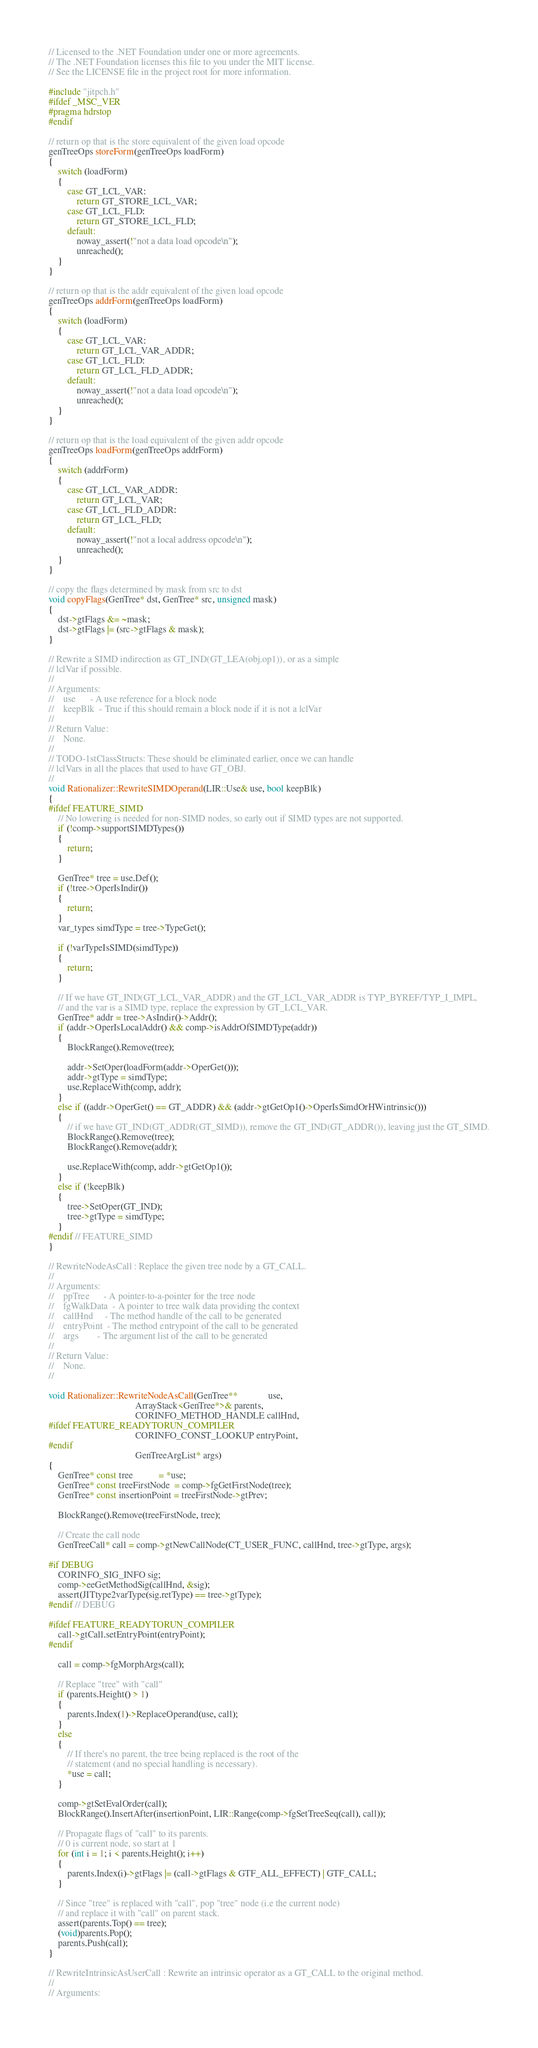Convert code to text. <code><loc_0><loc_0><loc_500><loc_500><_C++_>// Licensed to the .NET Foundation under one or more agreements.
// The .NET Foundation licenses this file to you under the MIT license.
// See the LICENSE file in the project root for more information.

#include "jitpch.h"
#ifdef _MSC_VER
#pragma hdrstop
#endif

// return op that is the store equivalent of the given load opcode
genTreeOps storeForm(genTreeOps loadForm)
{
    switch (loadForm)
    {
        case GT_LCL_VAR:
            return GT_STORE_LCL_VAR;
        case GT_LCL_FLD:
            return GT_STORE_LCL_FLD;
        default:
            noway_assert(!"not a data load opcode\n");
            unreached();
    }
}

// return op that is the addr equivalent of the given load opcode
genTreeOps addrForm(genTreeOps loadForm)
{
    switch (loadForm)
    {
        case GT_LCL_VAR:
            return GT_LCL_VAR_ADDR;
        case GT_LCL_FLD:
            return GT_LCL_FLD_ADDR;
        default:
            noway_assert(!"not a data load opcode\n");
            unreached();
    }
}

// return op that is the load equivalent of the given addr opcode
genTreeOps loadForm(genTreeOps addrForm)
{
    switch (addrForm)
    {
        case GT_LCL_VAR_ADDR:
            return GT_LCL_VAR;
        case GT_LCL_FLD_ADDR:
            return GT_LCL_FLD;
        default:
            noway_assert(!"not a local address opcode\n");
            unreached();
    }
}

// copy the flags determined by mask from src to dst
void copyFlags(GenTree* dst, GenTree* src, unsigned mask)
{
    dst->gtFlags &= ~mask;
    dst->gtFlags |= (src->gtFlags & mask);
}

// Rewrite a SIMD indirection as GT_IND(GT_LEA(obj.op1)), or as a simple
// lclVar if possible.
//
// Arguments:
//    use      - A use reference for a block node
//    keepBlk  - True if this should remain a block node if it is not a lclVar
//
// Return Value:
//    None.
//
// TODO-1stClassStructs: These should be eliminated earlier, once we can handle
// lclVars in all the places that used to have GT_OBJ.
//
void Rationalizer::RewriteSIMDOperand(LIR::Use& use, bool keepBlk)
{
#ifdef FEATURE_SIMD
    // No lowering is needed for non-SIMD nodes, so early out if SIMD types are not supported.
    if (!comp->supportSIMDTypes())
    {
        return;
    }

    GenTree* tree = use.Def();
    if (!tree->OperIsIndir())
    {
        return;
    }
    var_types simdType = tree->TypeGet();

    if (!varTypeIsSIMD(simdType))
    {
        return;
    }

    // If we have GT_IND(GT_LCL_VAR_ADDR) and the GT_LCL_VAR_ADDR is TYP_BYREF/TYP_I_IMPL,
    // and the var is a SIMD type, replace the expression by GT_LCL_VAR.
    GenTree* addr = tree->AsIndir()->Addr();
    if (addr->OperIsLocalAddr() && comp->isAddrOfSIMDType(addr))
    {
        BlockRange().Remove(tree);

        addr->SetOper(loadForm(addr->OperGet()));
        addr->gtType = simdType;
        use.ReplaceWith(comp, addr);
    }
    else if ((addr->OperGet() == GT_ADDR) && (addr->gtGetOp1()->OperIsSimdOrHWintrinsic()))
    {
        // if we have GT_IND(GT_ADDR(GT_SIMD)), remove the GT_IND(GT_ADDR()), leaving just the GT_SIMD.
        BlockRange().Remove(tree);
        BlockRange().Remove(addr);

        use.ReplaceWith(comp, addr->gtGetOp1());
    }
    else if (!keepBlk)
    {
        tree->SetOper(GT_IND);
        tree->gtType = simdType;
    }
#endif // FEATURE_SIMD
}

// RewriteNodeAsCall : Replace the given tree node by a GT_CALL.
//
// Arguments:
//    ppTree      - A pointer-to-a-pointer for the tree node
//    fgWalkData  - A pointer to tree walk data providing the context
//    callHnd     - The method handle of the call to be generated
//    entryPoint  - The method entrypoint of the call to be generated
//    args        - The argument list of the call to be generated
//
// Return Value:
//    None.
//

void Rationalizer::RewriteNodeAsCall(GenTree**             use,
                                     ArrayStack<GenTree*>& parents,
                                     CORINFO_METHOD_HANDLE callHnd,
#ifdef FEATURE_READYTORUN_COMPILER
                                     CORINFO_CONST_LOOKUP entryPoint,
#endif
                                     GenTreeArgList* args)
{
    GenTree* const tree           = *use;
    GenTree* const treeFirstNode  = comp->fgGetFirstNode(tree);
    GenTree* const insertionPoint = treeFirstNode->gtPrev;

    BlockRange().Remove(treeFirstNode, tree);

    // Create the call node
    GenTreeCall* call = comp->gtNewCallNode(CT_USER_FUNC, callHnd, tree->gtType, args);

#if DEBUG
    CORINFO_SIG_INFO sig;
    comp->eeGetMethodSig(callHnd, &sig);
    assert(JITtype2varType(sig.retType) == tree->gtType);
#endif // DEBUG

#ifdef FEATURE_READYTORUN_COMPILER
    call->gtCall.setEntryPoint(entryPoint);
#endif

    call = comp->fgMorphArgs(call);

    // Replace "tree" with "call"
    if (parents.Height() > 1)
    {
        parents.Index(1)->ReplaceOperand(use, call);
    }
    else
    {
        // If there's no parent, the tree being replaced is the root of the
        // statement (and no special handling is necessary).
        *use = call;
    }

    comp->gtSetEvalOrder(call);
    BlockRange().InsertAfter(insertionPoint, LIR::Range(comp->fgSetTreeSeq(call), call));

    // Propagate flags of "call" to its parents.
    // 0 is current node, so start at 1
    for (int i = 1; i < parents.Height(); i++)
    {
        parents.Index(i)->gtFlags |= (call->gtFlags & GTF_ALL_EFFECT) | GTF_CALL;
    }

    // Since "tree" is replaced with "call", pop "tree" node (i.e the current node)
    // and replace it with "call" on parent stack.
    assert(parents.Top() == tree);
    (void)parents.Pop();
    parents.Push(call);
}

// RewriteIntrinsicAsUserCall : Rewrite an intrinsic operator as a GT_CALL to the original method.
//
// Arguments:</code> 